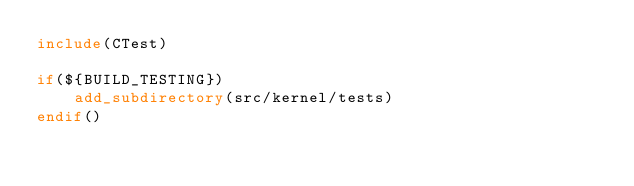Convert code to text. <code><loc_0><loc_0><loc_500><loc_500><_CMake_>include(CTest)

if(${BUILD_TESTING})
    add_subdirectory(src/kernel/tests)
endif()
</code> 